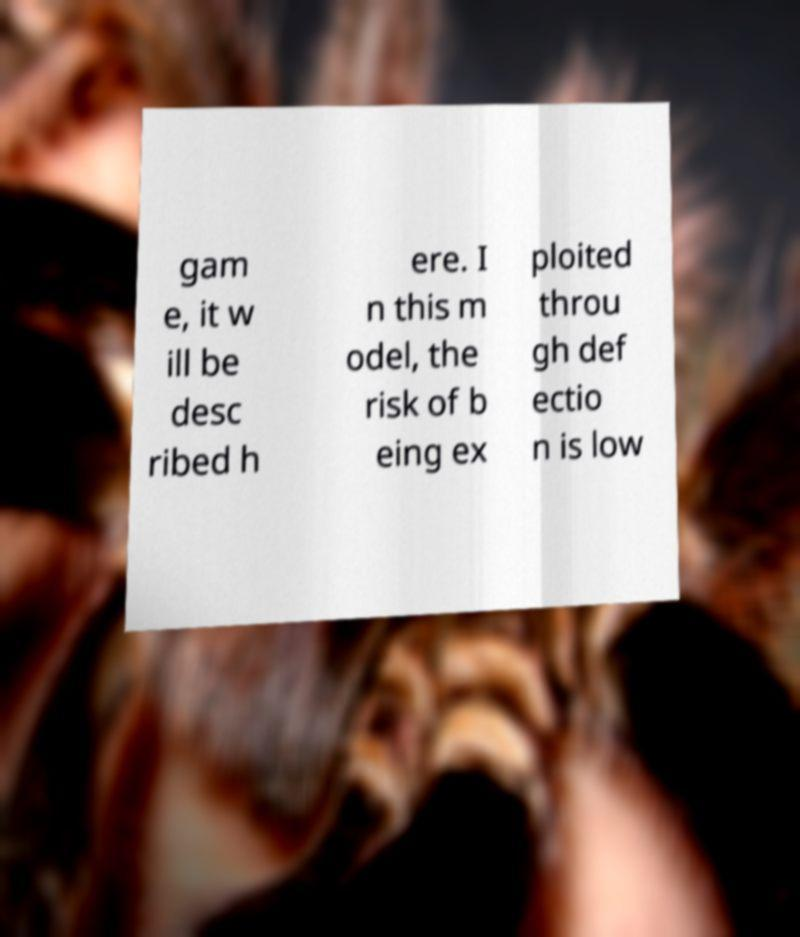Could you extract and type out the text from this image? gam e, it w ill be desc ribed h ere. I n this m odel, the risk of b eing ex ploited throu gh def ectio n is low 